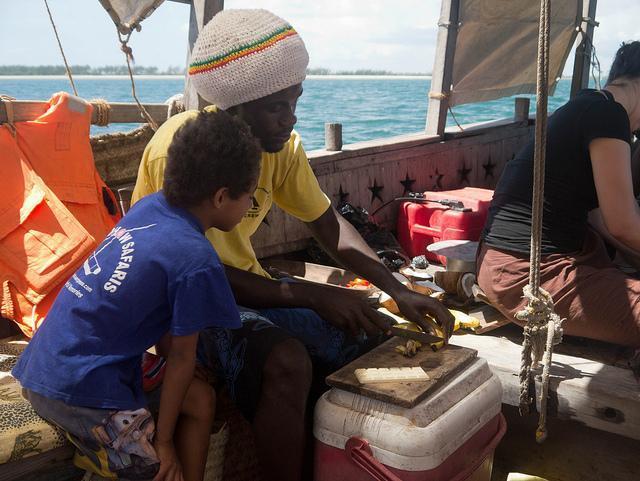How many people are in the picture?
Give a very brief answer. 3. 